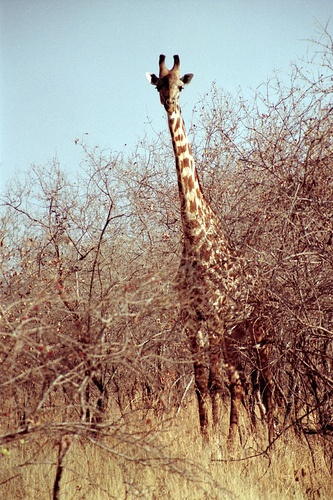Describe the objects in this image and their specific colors. I can see a giraffe in darkgray, maroon, brown, black, and tan tones in this image. 